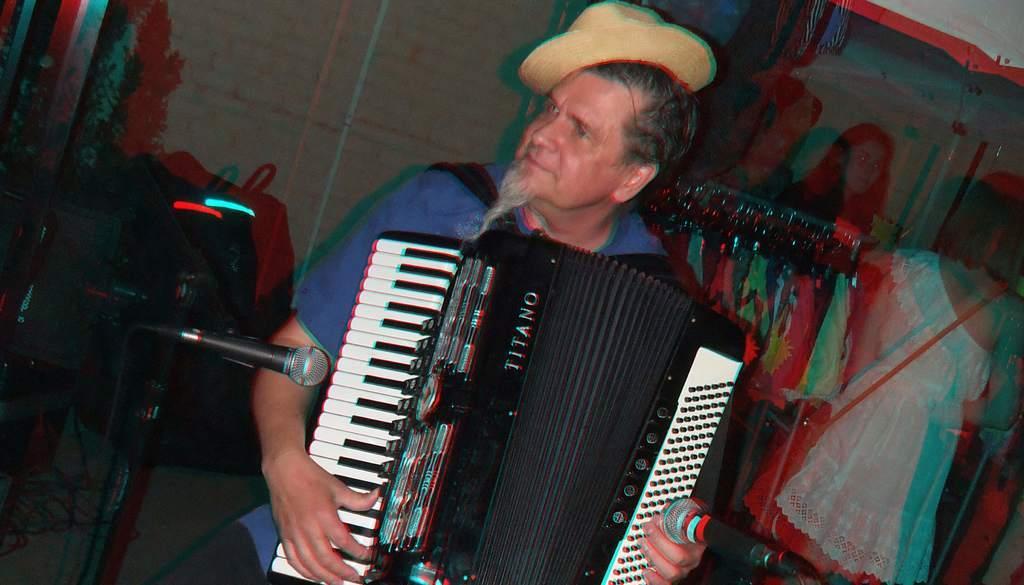Please provide a concise description of this image. In this image there is a person playing a musical instrument, in front of the person there are mice, behind the person there are clothes on the hanger, behind the hanger there is a wall. 